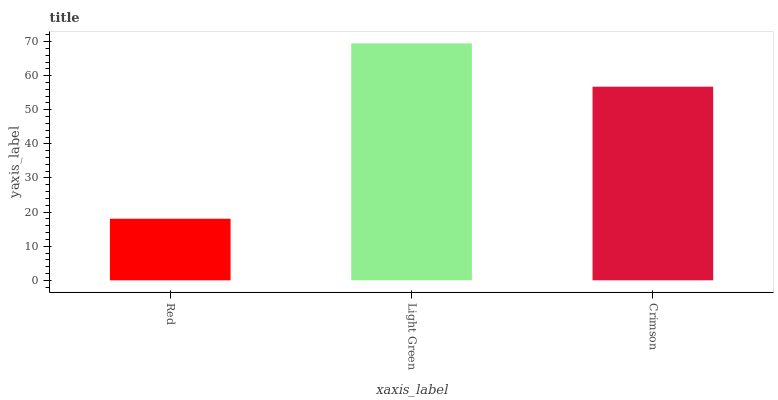Is Red the minimum?
Answer yes or no. Yes. Is Light Green the maximum?
Answer yes or no. Yes. Is Crimson the minimum?
Answer yes or no. No. Is Crimson the maximum?
Answer yes or no. No. Is Light Green greater than Crimson?
Answer yes or no. Yes. Is Crimson less than Light Green?
Answer yes or no. Yes. Is Crimson greater than Light Green?
Answer yes or no. No. Is Light Green less than Crimson?
Answer yes or no. No. Is Crimson the high median?
Answer yes or no. Yes. Is Crimson the low median?
Answer yes or no. Yes. Is Light Green the high median?
Answer yes or no. No. Is Red the low median?
Answer yes or no. No. 